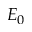Convert formula to latex. <formula><loc_0><loc_0><loc_500><loc_500>E _ { 0 }</formula> 